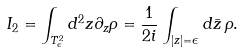<formula> <loc_0><loc_0><loc_500><loc_500>I _ { 2 } = \int _ { T _ { \epsilon } ^ { 2 } } d ^ { 2 } z \partial _ { z } \rho = \frac { 1 } { 2 i } \int _ { | z | = \epsilon } d \bar { z } \, \rho .</formula> 